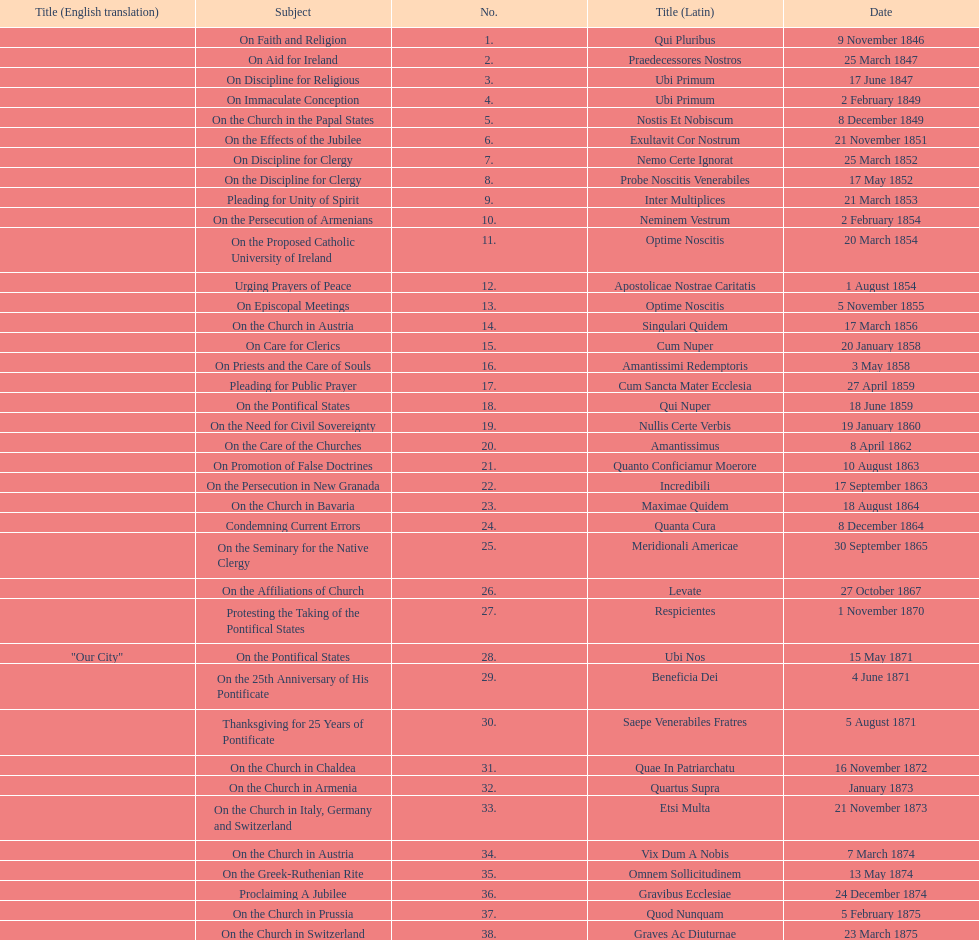How many subjects are there? 38. 